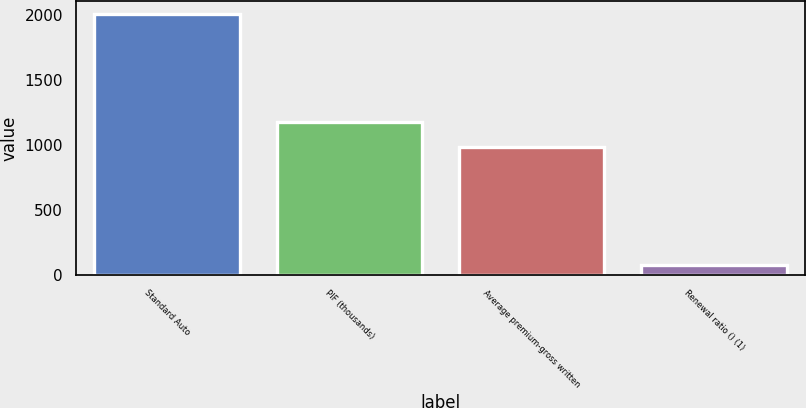Convert chart. <chart><loc_0><loc_0><loc_500><loc_500><bar_chart><fcel>Standard Auto<fcel>PIF (thousands)<fcel>Average premium-gross written<fcel>Renewal ratio () (1)<nl><fcel>2006<fcel>1175.96<fcel>983<fcel>76.4<nl></chart> 